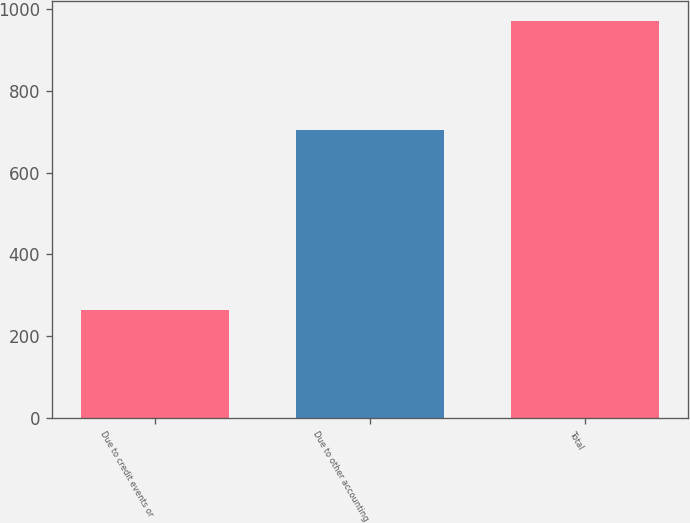<chart> <loc_0><loc_0><loc_500><loc_500><bar_chart><fcel>Due to credit events or<fcel>Due to other accounting<fcel>Total<nl><fcel>265<fcel>705<fcel>970<nl></chart> 